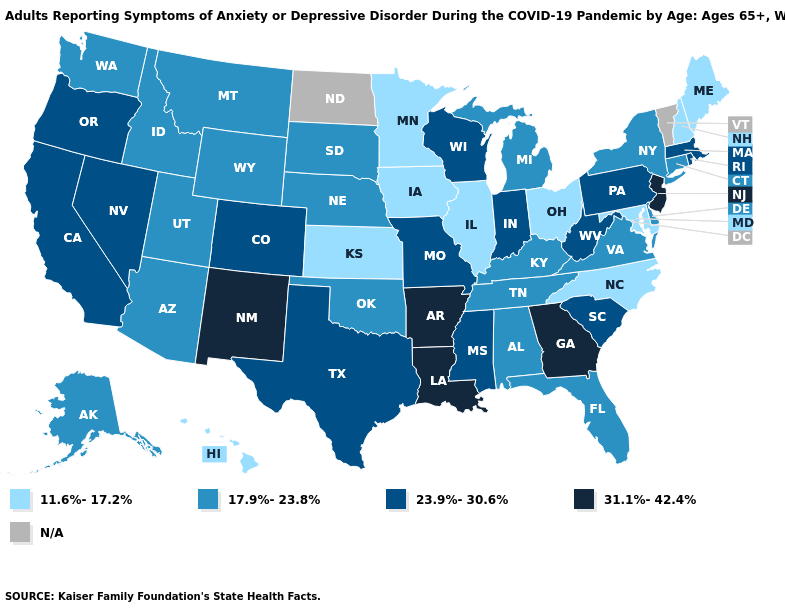What is the value of Massachusetts?
Answer briefly. 23.9%-30.6%. Name the states that have a value in the range 11.6%-17.2%?
Be succinct. Hawaii, Illinois, Iowa, Kansas, Maine, Maryland, Minnesota, New Hampshire, North Carolina, Ohio. What is the highest value in the USA?
Answer briefly. 31.1%-42.4%. What is the lowest value in states that border Oregon?
Short answer required. 17.9%-23.8%. What is the highest value in states that border New Mexico?
Give a very brief answer. 23.9%-30.6%. Name the states that have a value in the range N/A?
Answer briefly. North Dakota, Vermont. Name the states that have a value in the range N/A?
Quick response, please. North Dakota, Vermont. Among the states that border Connecticut , does New York have the lowest value?
Quick response, please. Yes. Name the states that have a value in the range N/A?
Give a very brief answer. North Dakota, Vermont. Name the states that have a value in the range 23.9%-30.6%?
Short answer required. California, Colorado, Indiana, Massachusetts, Mississippi, Missouri, Nevada, Oregon, Pennsylvania, Rhode Island, South Carolina, Texas, West Virginia, Wisconsin. Name the states that have a value in the range 31.1%-42.4%?
Keep it brief. Arkansas, Georgia, Louisiana, New Jersey, New Mexico. What is the value of Oregon?
Quick response, please. 23.9%-30.6%. Which states hav the highest value in the MidWest?
Answer briefly. Indiana, Missouri, Wisconsin. 